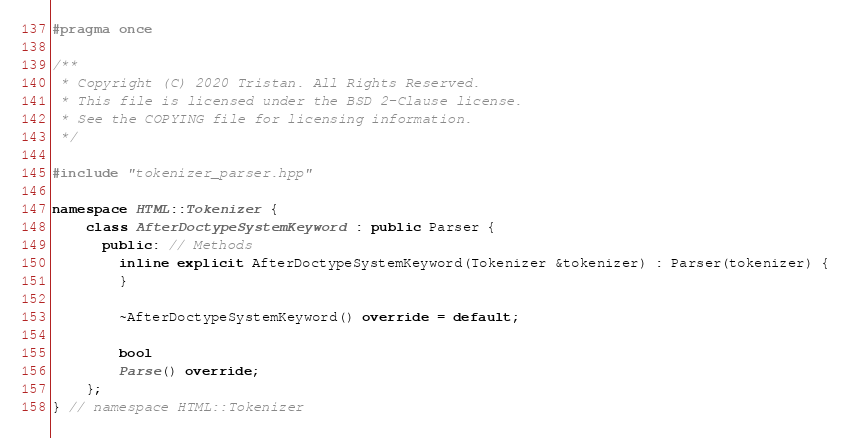<code> <loc_0><loc_0><loc_500><loc_500><_C++_>#pragma once

/**
 * Copyright (C) 2020 Tristan. All Rights Reserved.
 * This file is licensed under the BSD 2-Clause license.
 * See the COPYING file for licensing information.
 */

#include "tokenizer_parser.hpp"

namespace HTML::Tokenizer {
	class AfterDoctypeSystemKeyword : public Parser {
	  public: // Methods
		inline explicit AfterDoctypeSystemKeyword(Tokenizer &tokenizer) : Parser(tokenizer) {
		}

		~AfterDoctypeSystemKeyword() override = default;

		bool
		Parse() override;
	};
} // namespace HTML::Tokenizer
</code> 